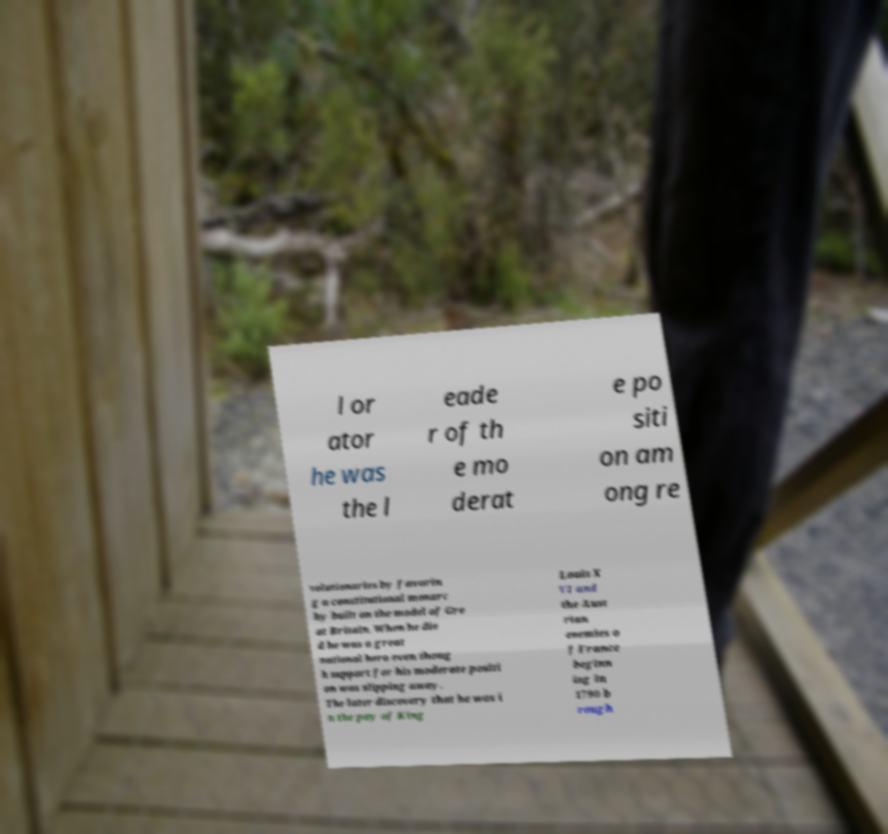Can you accurately transcribe the text from the provided image for me? l or ator he was the l eade r of th e mo derat e po siti on am ong re volutionaries by favorin g a constitutional monarc hy built on the model of Gre at Britain. When he die d he was a great national hero even thoug h support for his moderate positi on was slipping away. The later discovery that he was i n the pay of King Louis X VI and the Aust rian enemies o f France beginn ing in 1790 b rough 